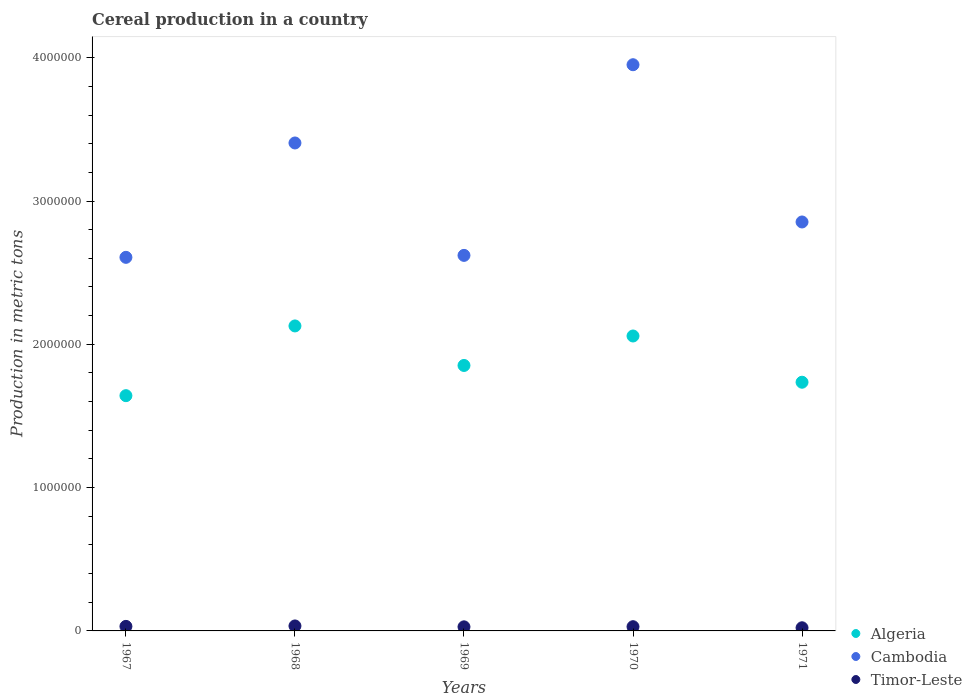Is the number of dotlines equal to the number of legend labels?
Offer a terse response. Yes. What is the total cereal production in Timor-Leste in 1968?
Offer a terse response. 3.47e+04. Across all years, what is the maximum total cereal production in Algeria?
Keep it short and to the point. 2.13e+06. Across all years, what is the minimum total cereal production in Timor-Leste?
Offer a terse response. 2.20e+04. In which year was the total cereal production in Cambodia minimum?
Provide a succinct answer. 1967. What is the total total cereal production in Timor-Leste in the graph?
Provide a succinct answer. 1.46e+05. What is the difference between the total cereal production in Algeria in 1967 and that in 1969?
Ensure brevity in your answer.  -2.11e+05. What is the difference between the total cereal production in Cambodia in 1969 and the total cereal production in Timor-Leste in 1967?
Your answer should be compact. 2.59e+06. What is the average total cereal production in Cambodia per year?
Make the answer very short. 3.09e+06. In the year 1969, what is the difference between the total cereal production in Timor-Leste and total cereal production in Algeria?
Offer a terse response. -1.82e+06. In how many years, is the total cereal production in Timor-Leste greater than 2800000 metric tons?
Your response must be concise. 0. What is the ratio of the total cereal production in Cambodia in 1968 to that in 1969?
Ensure brevity in your answer.  1.3. Is the difference between the total cereal production in Timor-Leste in 1968 and 1969 greater than the difference between the total cereal production in Algeria in 1968 and 1969?
Your answer should be very brief. No. What is the difference between the highest and the second highest total cereal production in Algeria?
Keep it short and to the point. 7.01e+04. What is the difference between the highest and the lowest total cereal production in Timor-Leste?
Offer a terse response. 1.28e+04. Is the sum of the total cereal production in Timor-Leste in 1967 and 1971 greater than the maximum total cereal production in Algeria across all years?
Ensure brevity in your answer.  No. Does the total cereal production in Timor-Leste monotonically increase over the years?
Provide a short and direct response. No. Is the total cereal production in Cambodia strictly greater than the total cereal production in Timor-Leste over the years?
Provide a short and direct response. Yes. What is the difference between two consecutive major ticks on the Y-axis?
Provide a succinct answer. 1.00e+06. Does the graph contain grids?
Your answer should be very brief. No. How are the legend labels stacked?
Your answer should be compact. Vertical. What is the title of the graph?
Your response must be concise. Cereal production in a country. Does "Croatia" appear as one of the legend labels in the graph?
Provide a succinct answer. No. What is the label or title of the X-axis?
Ensure brevity in your answer.  Years. What is the label or title of the Y-axis?
Ensure brevity in your answer.  Production in metric tons. What is the Production in metric tons of Algeria in 1967?
Your answer should be very brief. 1.64e+06. What is the Production in metric tons of Cambodia in 1967?
Offer a terse response. 2.61e+06. What is the Production in metric tons in Timor-Leste in 1967?
Your answer should be compact. 3.16e+04. What is the Production in metric tons of Algeria in 1968?
Your answer should be very brief. 2.13e+06. What is the Production in metric tons in Cambodia in 1968?
Your answer should be compact. 3.40e+06. What is the Production in metric tons of Timor-Leste in 1968?
Ensure brevity in your answer.  3.47e+04. What is the Production in metric tons in Algeria in 1969?
Keep it short and to the point. 1.85e+06. What is the Production in metric tons in Cambodia in 1969?
Offer a terse response. 2.62e+06. What is the Production in metric tons of Timor-Leste in 1969?
Offer a terse response. 2.85e+04. What is the Production in metric tons in Algeria in 1970?
Keep it short and to the point. 2.06e+06. What is the Production in metric tons of Cambodia in 1970?
Provide a short and direct response. 3.95e+06. What is the Production in metric tons in Timor-Leste in 1970?
Provide a succinct answer. 2.95e+04. What is the Production in metric tons of Algeria in 1971?
Provide a succinct answer. 1.74e+06. What is the Production in metric tons in Cambodia in 1971?
Your response must be concise. 2.85e+06. What is the Production in metric tons of Timor-Leste in 1971?
Your answer should be compact. 2.20e+04. Across all years, what is the maximum Production in metric tons of Algeria?
Your response must be concise. 2.13e+06. Across all years, what is the maximum Production in metric tons of Cambodia?
Provide a short and direct response. 3.95e+06. Across all years, what is the maximum Production in metric tons of Timor-Leste?
Keep it short and to the point. 3.47e+04. Across all years, what is the minimum Production in metric tons of Algeria?
Make the answer very short. 1.64e+06. Across all years, what is the minimum Production in metric tons in Cambodia?
Offer a terse response. 2.61e+06. Across all years, what is the minimum Production in metric tons in Timor-Leste?
Your response must be concise. 2.20e+04. What is the total Production in metric tons of Algeria in the graph?
Provide a short and direct response. 9.42e+06. What is the total Production in metric tons in Cambodia in the graph?
Your response must be concise. 1.54e+07. What is the total Production in metric tons of Timor-Leste in the graph?
Make the answer very short. 1.46e+05. What is the difference between the Production in metric tons of Algeria in 1967 and that in 1968?
Give a very brief answer. -4.87e+05. What is the difference between the Production in metric tons in Cambodia in 1967 and that in 1968?
Give a very brief answer. -7.98e+05. What is the difference between the Production in metric tons of Timor-Leste in 1967 and that in 1968?
Your answer should be very brief. -3103. What is the difference between the Production in metric tons in Algeria in 1967 and that in 1969?
Ensure brevity in your answer.  -2.11e+05. What is the difference between the Production in metric tons in Cambodia in 1967 and that in 1969?
Your answer should be compact. -1.37e+04. What is the difference between the Production in metric tons in Timor-Leste in 1967 and that in 1969?
Your response must be concise. 3145. What is the difference between the Production in metric tons in Algeria in 1967 and that in 1970?
Provide a short and direct response. -4.16e+05. What is the difference between the Production in metric tons of Cambodia in 1967 and that in 1970?
Offer a very short reply. -1.34e+06. What is the difference between the Production in metric tons in Timor-Leste in 1967 and that in 1970?
Make the answer very short. 2125. What is the difference between the Production in metric tons in Algeria in 1967 and that in 1971?
Ensure brevity in your answer.  -9.37e+04. What is the difference between the Production in metric tons of Cambodia in 1967 and that in 1971?
Ensure brevity in your answer.  -2.47e+05. What is the difference between the Production in metric tons in Timor-Leste in 1967 and that in 1971?
Make the answer very short. 9666. What is the difference between the Production in metric tons in Algeria in 1968 and that in 1969?
Keep it short and to the point. 2.76e+05. What is the difference between the Production in metric tons of Cambodia in 1968 and that in 1969?
Ensure brevity in your answer.  7.84e+05. What is the difference between the Production in metric tons of Timor-Leste in 1968 and that in 1969?
Provide a short and direct response. 6248. What is the difference between the Production in metric tons in Algeria in 1968 and that in 1970?
Your answer should be compact. 7.01e+04. What is the difference between the Production in metric tons in Cambodia in 1968 and that in 1970?
Make the answer very short. -5.46e+05. What is the difference between the Production in metric tons in Timor-Leste in 1968 and that in 1970?
Your answer should be compact. 5228. What is the difference between the Production in metric tons in Algeria in 1968 and that in 1971?
Provide a short and direct response. 3.93e+05. What is the difference between the Production in metric tons in Cambodia in 1968 and that in 1971?
Offer a terse response. 5.51e+05. What is the difference between the Production in metric tons in Timor-Leste in 1968 and that in 1971?
Offer a very short reply. 1.28e+04. What is the difference between the Production in metric tons in Algeria in 1969 and that in 1970?
Your answer should be very brief. -2.06e+05. What is the difference between the Production in metric tons of Cambodia in 1969 and that in 1970?
Your answer should be compact. -1.33e+06. What is the difference between the Production in metric tons of Timor-Leste in 1969 and that in 1970?
Provide a short and direct response. -1020. What is the difference between the Production in metric tons of Algeria in 1969 and that in 1971?
Offer a very short reply. 1.17e+05. What is the difference between the Production in metric tons of Cambodia in 1969 and that in 1971?
Your response must be concise. -2.33e+05. What is the difference between the Production in metric tons in Timor-Leste in 1969 and that in 1971?
Provide a short and direct response. 6521. What is the difference between the Production in metric tons of Algeria in 1970 and that in 1971?
Make the answer very short. 3.23e+05. What is the difference between the Production in metric tons of Cambodia in 1970 and that in 1971?
Your answer should be compact. 1.10e+06. What is the difference between the Production in metric tons in Timor-Leste in 1970 and that in 1971?
Provide a short and direct response. 7541. What is the difference between the Production in metric tons in Algeria in 1967 and the Production in metric tons in Cambodia in 1968?
Offer a terse response. -1.76e+06. What is the difference between the Production in metric tons in Algeria in 1967 and the Production in metric tons in Timor-Leste in 1968?
Your response must be concise. 1.61e+06. What is the difference between the Production in metric tons in Cambodia in 1967 and the Production in metric tons in Timor-Leste in 1968?
Offer a terse response. 2.57e+06. What is the difference between the Production in metric tons in Algeria in 1967 and the Production in metric tons in Cambodia in 1969?
Make the answer very short. -9.79e+05. What is the difference between the Production in metric tons in Algeria in 1967 and the Production in metric tons in Timor-Leste in 1969?
Keep it short and to the point. 1.61e+06. What is the difference between the Production in metric tons in Cambodia in 1967 and the Production in metric tons in Timor-Leste in 1969?
Offer a very short reply. 2.58e+06. What is the difference between the Production in metric tons in Algeria in 1967 and the Production in metric tons in Cambodia in 1970?
Offer a terse response. -2.31e+06. What is the difference between the Production in metric tons of Algeria in 1967 and the Production in metric tons of Timor-Leste in 1970?
Offer a terse response. 1.61e+06. What is the difference between the Production in metric tons in Cambodia in 1967 and the Production in metric tons in Timor-Leste in 1970?
Your answer should be compact. 2.58e+06. What is the difference between the Production in metric tons in Algeria in 1967 and the Production in metric tons in Cambodia in 1971?
Your response must be concise. -1.21e+06. What is the difference between the Production in metric tons in Algeria in 1967 and the Production in metric tons in Timor-Leste in 1971?
Keep it short and to the point. 1.62e+06. What is the difference between the Production in metric tons of Cambodia in 1967 and the Production in metric tons of Timor-Leste in 1971?
Provide a succinct answer. 2.58e+06. What is the difference between the Production in metric tons in Algeria in 1968 and the Production in metric tons in Cambodia in 1969?
Offer a terse response. -4.92e+05. What is the difference between the Production in metric tons of Algeria in 1968 and the Production in metric tons of Timor-Leste in 1969?
Provide a short and direct response. 2.10e+06. What is the difference between the Production in metric tons of Cambodia in 1968 and the Production in metric tons of Timor-Leste in 1969?
Provide a succinct answer. 3.38e+06. What is the difference between the Production in metric tons of Algeria in 1968 and the Production in metric tons of Cambodia in 1970?
Your answer should be very brief. -1.82e+06. What is the difference between the Production in metric tons in Algeria in 1968 and the Production in metric tons in Timor-Leste in 1970?
Your answer should be compact. 2.10e+06. What is the difference between the Production in metric tons in Cambodia in 1968 and the Production in metric tons in Timor-Leste in 1970?
Offer a very short reply. 3.38e+06. What is the difference between the Production in metric tons of Algeria in 1968 and the Production in metric tons of Cambodia in 1971?
Offer a terse response. -7.25e+05. What is the difference between the Production in metric tons in Algeria in 1968 and the Production in metric tons in Timor-Leste in 1971?
Make the answer very short. 2.11e+06. What is the difference between the Production in metric tons of Cambodia in 1968 and the Production in metric tons of Timor-Leste in 1971?
Ensure brevity in your answer.  3.38e+06. What is the difference between the Production in metric tons in Algeria in 1969 and the Production in metric tons in Cambodia in 1970?
Keep it short and to the point. -2.10e+06. What is the difference between the Production in metric tons in Algeria in 1969 and the Production in metric tons in Timor-Leste in 1970?
Give a very brief answer. 1.82e+06. What is the difference between the Production in metric tons in Cambodia in 1969 and the Production in metric tons in Timor-Leste in 1970?
Provide a short and direct response. 2.59e+06. What is the difference between the Production in metric tons in Algeria in 1969 and the Production in metric tons in Cambodia in 1971?
Your answer should be very brief. -1.00e+06. What is the difference between the Production in metric tons in Algeria in 1969 and the Production in metric tons in Timor-Leste in 1971?
Give a very brief answer. 1.83e+06. What is the difference between the Production in metric tons in Cambodia in 1969 and the Production in metric tons in Timor-Leste in 1971?
Offer a terse response. 2.60e+06. What is the difference between the Production in metric tons in Algeria in 1970 and the Production in metric tons in Cambodia in 1971?
Keep it short and to the point. -7.96e+05. What is the difference between the Production in metric tons of Algeria in 1970 and the Production in metric tons of Timor-Leste in 1971?
Give a very brief answer. 2.04e+06. What is the difference between the Production in metric tons of Cambodia in 1970 and the Production in metric tons of Timor-Leste in 1971?
Provide a short and direct response. 3.93e+06. What is the average Production in metric tons in Algeria per year?
Provide a succinct answer. 1.88e+06. What is the average Production in metric tons in Cambodia per year?
Your answer should be compact. 3.09e+06. What is the average Production in metric tons in Timor-Leste per year?
Provide a succinct answer. 2.93e+04. In the year 1967, what is the difference between the Production in metric tons in Algeria and Production in metric tons in Cambodia?
Make the answer very short. -9.65e+05. In the year 1967, what is the difference between the Production in metric tons in Algeria and Production in metric tons in Timor-Leste?
Provide a short and direct response. 1.61e+06. In the year 1967, what is the difference between the Production in metric tons of Cambodia and Production in metric tons of Timor-Leste?
Your response must be concise. 2.58e+06. In the year 1968, what is the difference between the Production in metric tons in Algeria and Production in metric tons in Cambodia?
Offer a terse response. -1.28e+06. In the year 1968, what is the difference between the Production in metric tons of Algeria and Production in metric tons of Timor-Leste?
Ensure brevity in your answer.  2.09e+06. In the year 1968, what is the difference between the Production in metric tons of Cambodia and Production in metric tons of Timor-Leste?
Provide a succinct answer. 3.37e+06. In the year 1969, what is the difference between the Production in metric tons in Algeria and Production in metric tons in Cambodia?
Make the answer very short. -7.68e+05. In the year 1969, what is the difference between the Production in metric tons in Algeria and Production in metric tons in Timor-Leste?
Provide a short and direct response. 1.82e+06. In the year 1969, what is the difference between the Production in metric tons in Cambodia and Production in metric tons in Timor-Leste?
Your answer should be very brief. 2.59e+06. In the year 1970, what is the difference between the Production in metric tons in Algeria and Production in metric tons in Cambodia?
Provide a short and direct response. -1.89e+06. In the year 1970, what is the difference between the Production in metric tons of Algeria and Production in metric tons of Timor-Leste?
Your answer should be very brief. 2.03e+06. In the year 1970, what is the difference between the Production in metric tons of Cambodia and Production in metric tons of Timor-Leste?
Provide a succinct answer. 3.92e+06. In the year 1971, what is the difference between the Production in metric tons of Algeria and Production in metric tons of Cambodia?
Ensure brevity in your answer.  -1.12e+06. In the year 1971, what is the difference between the Production in metric tons of Algeria and Production in metric tons of Timor-Leste?
Your answer should be very brief. 1.71e+06. In the year 1971, what is the difference between the Production in metric tons of Cambodia and Production in metric tons of Timor-Leste?
Offer a terse response. 2.83e+06. What is the ratio of the Production in metric tons in Algeria in 1967 to that in 1968?
Your answer should be compact. 0.77. What is the ratio of the Production in metric tons of Cambodia in 1967 to that in 1968?
Give a very brief answer. 0.77. What is the ratio of the Production in metric tons of Timor-Leste in 1967 to that in 1968?
Keep it short and to the point. 0.91. What is the ratio of the Production in metric tons of Algeria in 1967 to that in 1969?
Provide a short and direct response. 0.89. What is the ratio of the Production in metric tons of Timor-Leste in 1967 to that in 1969?
Offer a terse response. 1.11. What is the ratio of the Production in metric tons of Algeria in 1967 to that in 1970?
Provide a succinct answer. 0.8. What is the ratio of the Production in metric tons of Cambodia in 1967 to that in 1970?
Offer a very short reply. 0.66. What is the ratio of the Production in metric tons in Timor-Leste in 1967 to that in 1970?
Make the answer very short. 1.07. What is the ratio of the Production in metric tons of Algeria in 1967 to that in 1971?
Your answer should be compact. 0.95. What is the ratio of the Production in metric tons in Cambodia in 1967 to that in 1971?
Provide a short and direct response. 0.91. What is the ratio of the Production in metric tons in Timor-Leste in 1967 to that in 1971?
Make the answer very short. 1.44. What is the ratio of the Production in metric tons in Algeria in 1968 to that in 1969?
Your answer should be very brief. 1.15. What is the ratio of the Production in metric tons in Cambodia in 1968 to that in 1969?
Your answer should be compact. 1.3. What is the ratio of the Production in metric tons in Timor-Leste in 1968 to that in 1969?
Offer a terse response. 1.22. What is the ratio of the Production in metric tons of Algeria in 1968 to that in 1970?
Provide a succinct answer. 1.03. What is the ratio of the Production in metric tons of Cambodia in 1968 to that in 1970?
Make the answer very short. 0.86. What is the ratio of the Production in metric tons of Timor-Leste in 1968 to that in 1970?
Your answer should be very brief. 1.18. What is the ratio of the Production in metric tons of Algeria in 1968 to that in 1971?
Provide a short and direct response. 1.23. What is the ratio of the Production in metric tons in Cambodia in 1968 to that in 1971?
Your answer should be compact. 1.19. What is the ratio of the Production in metric tons of Timor-Leste in 1968 to that in 1971?
Give a very brief answer. 1.58. What is the ratio of the Production in metric tons of Algeria in 1969 to that in 1970?
Your answer should be compact. 0.9. What is the ratio of the Production in metric tons of Cambodia in 1969 to that in 1970?
Your answer should be very brief. 0.66. What is the ratio of the Production in metric tons in Timor-Leste in 1969 to that in 1970?
Offer a very short reply. 0.97. What is the ratio of the Production in metric tons in Algeria in 1969 to that in 1971?
Your answer should be compact. 1.07. What is the ratio of the Production in metric tons of Cambodia in 1969 to that in 1971?
Offer a very short reply. 0.92. What is the ratio of the Production in metric tons of Timor-Leste in 1969 to that in 1971?
Your response must be concise. 1.3. What is the ratio of the Production in metric tons in Algeria in 1970 to that in 1971?
Your answer should be compact. 1.19. What is the ratio of the Production in metric tons of Cambodia in 1970 to that in 1971?
Keep it short and to the point. 1.38. What is the ratio of the Production in metric tons in Timor-Leste in 1970 to that in 1971?
Your answer should be compact. 1.34. What is the difference between the highest and the second highest Production in metric tons of Algeria?
Offer a very short reply. 7.01e+04. What is the difference between the highest and the second highest Production in metric tons of Cambodia?
Keep it short and to the point. 5.46e+05. What is the difference between the highest and the second highest Production in metric tons of Timor-Leste?
Provide a succinct answer. 3103. What is the difference between the highest and the lowest Production in metric tons in Algeria?
Your answer should be very brief. 4.87e+05. What is the difference between the highest and the lowest Production in metric tons of Cambodia?
Your answer should be compact. 1.34e+06. What is the difference between the highest and the lowest Production in metric tons in Timor-Leste?
Provide a short and direct response. 1.28e+04. 